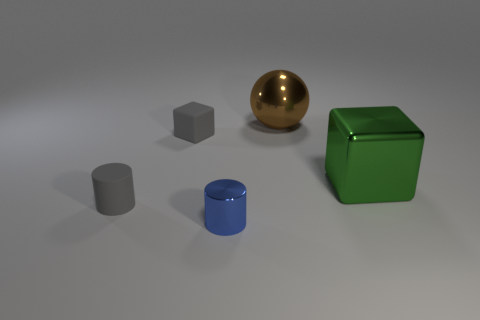Add 3 shiny blocks. How many objects exist? 8 Subtract all spheres. How many objects are left? 4 Add 1 cubes. How many cubes exist? 3 Subtract 0 purple spheres. How many objects are left? 5 Subtract all shiny blocks. Subtract all green metallic blocks. How many objects are left? 3 Add 5 tiny blue metallic cylinders. How many tiny blue metallic cylinders are left? 6 